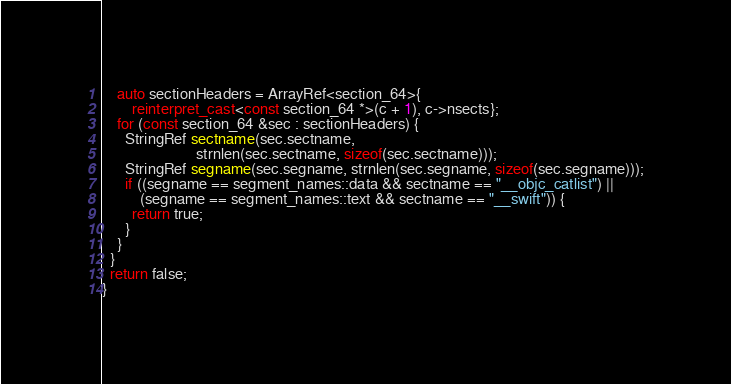<code> <loc_0><loc_0><loc_500><loc_500><_C++_>    auto sectionHeaders = ArrayRef<section_64>{
        reinterpret_cast<const section_64 *>(c + 1), c->nsects};
    for (const section_64 &sec : sectionHeaders) {
      StringRef sectname(sec.sectname,
                         strnlen(sec.sectname, sizeof(sec.sectname)));
      StringRef segname(sec.segname, strnlen(sec.segname, sizeof(sec.segname)));
      if ((segname == segment_names::data && sectname == "__objc_catlist") ||
          (segname == segment_names::text && sectname == "__swift")) {
        return true;
      }
    }
  }
  return false;
}
</code> 